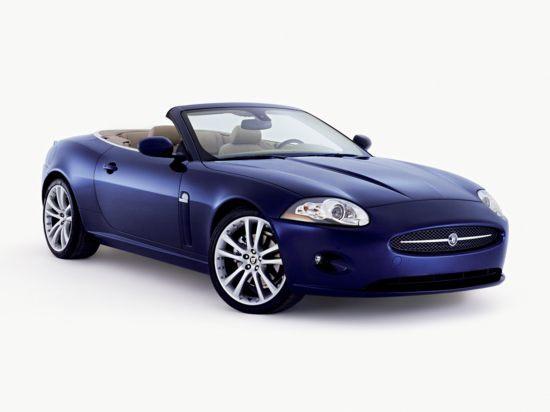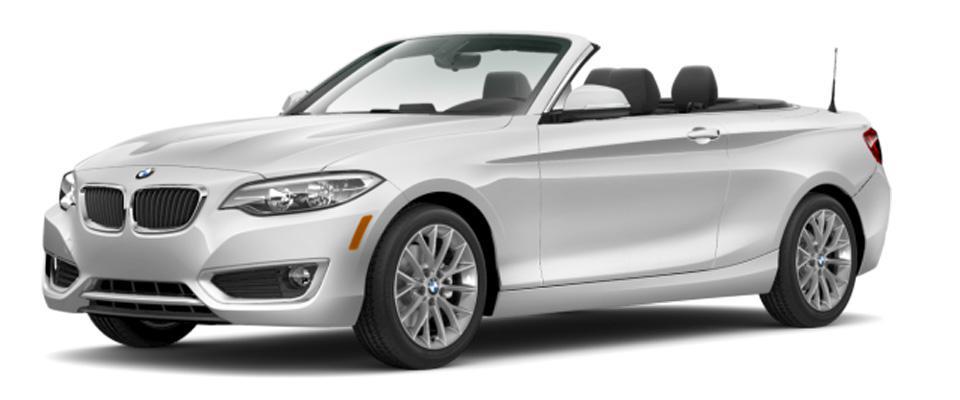The first image is the image on the left, the second image is the image on the right. Assess this claim about the two images: "One image shows a topless black convertible aimed leftward.". Correct or not? Answer yes or no. No. The first image is the image on the left, the second image is the image on the right. Given the left and right images, does the statement "There is no less than one black convertible car with its top down" hold true? Answer yes or no. No. 